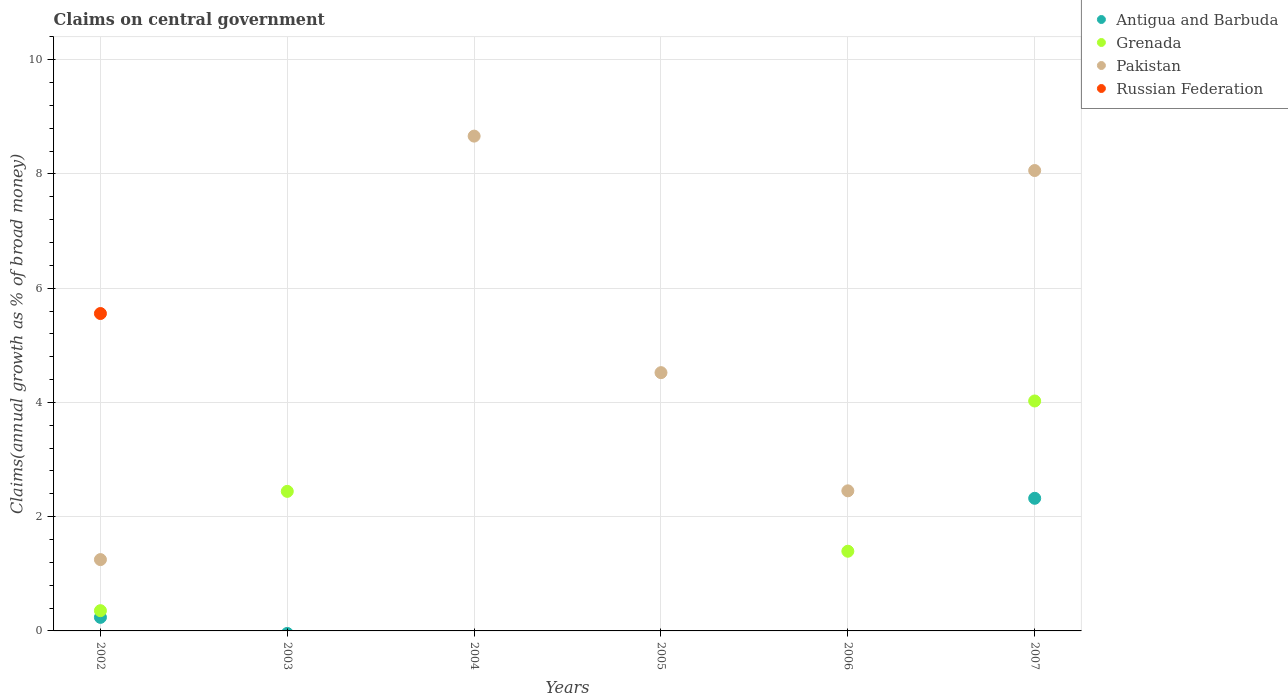Is the number of dotlines equal to the number of legend labels?
Your answer should be compact. No. Across all years, what is the maximum percentage of broad money claimed on centeral government in Russian Federation?
Offer a terse response. 5.56. Across all years, what is the minimum percentage of broad money claimed on centeral government in Pakistan?
Keep it short and to the point. 0. In which year was the percentage of broad money claimed on centeral government in Grenada maximum?
Provide a short and direct response. 2007. What is the total percentage of broad money claimed on centeral government in Russian Federation in the graph?
Provide a short and direct response. 5.56. What is the difference between the percentage of broad money claimed on centeral government in Grenada in 2003 and that in 2007?
Offer a terse response. -1.58. What is the difference between the percentage of broad money claimed on centeral government in Grenada in 2004 and the percentage of broad money claimed on centeral government in Pakistan in 2005?
Your answer should be compact. -4.52. What is the average percentage of broad money claimed on centeral government in Antigua and Barbuda per year?
Make the answer very short. 0.43. In the year 2007, what is the difference between the percentage of broad money claimed on centeral government in Antigua and Barbuda and percentage of broad money claimed on centeral government in Pakistan?
Offer a very short reply. -5.74. In how many years, is the percentage of broad money claimed on centeral government in Antigua and Barbuda greater than 0.8 %?
Ensure brevity in your answer.  1. Is the difference between the percentage of broad money claimed on centeral government in Antigua and Barbuda in 2002 and 2007 greater than the difference between the percentage of broad money claimed on centeral government in Pakistan in 2002 and 2007?
Give a very brief answer. Yes. What is the difference between the highest and the second highest percentage of broad money claimed on centeral government in Grenada?
Your answer should be compact. 1.58. What is the difference between the highest and the lowest percentage of broad money claimed on centeral government in Russian Federation?
Your answer should be compact. 5.56. Is it the case that in every year, the sum of the percentage of broad money claimed on centeral government in Grenada and percentage of broad money claimed on centeral government in Russian Federation  is greater than the sum of percentage of broad money claimed on centeral government in Pakistan and percentage of broad money claimed on centeral government in Antigua and Barbuda?
Provide a short and direct response. No. Is it the case that in every year, the sum of the percentage of broad money claimed on centeral government in Russian Federation and percentage of broad money claimed on centeral government in Grenada  is greater than the percentage of broad money claimed on centeral government in Antigua and Barbuda?
Keep it short and to the point. No. Does the percentage of broad money claimed on centeral government in Antigua and Barbuda monotonically increase over the years?
Ensure brevity in your answer.  No. Is the percentage of broad money claimed on centeral government in Grenada strictly less than the percentage of broad money claimed on centeral government in Russian Federation over the years?
Your answer should be very brief. No. What is the difference between two consecutive major ticks on the Y-axis?
Make the answer very short. 2. Are the values on the major ticks of Y-axis written in scientific E-notation?
Make the answer very short. No. Does the graph contain any zero values?
Your answer should be compact. Yes. Where does the legend appear in the graph?
Keep it short and to the point. Top right. How many legend labels are there?
Offer a very short reply. 4. How are the legend labels stacked?
Provide a short and direct response. Vertical. What is the title of the graph?
Provide a succinct answer. Claims on central government. What is the label or title of the Y-axis?
Your answer should be very brief. Claims(annual growth as % of broad money). What is the Claims(annual growth as % of broad money) in Antigua and Barbuda in 2002?
Provide a short and direct response. 0.24. What is the Claims(annual growth as % of broad money) of Grenada in 2002?
Offer a very short reply. 0.35. What is the Claims(annual growth as % of broad money) of Pakistan in 2002?
Your answer should be compact. 1.25. What is the Claims(annual growth as % of broad money) of Russian Federation in 2002?
Your answer should be very brief. 5.56. What is the Claims(annual growth as % of broad money) of Grenada in 2003?
Give a very brief answer. 2.44. What is the Claims(annual growth as % of broad money) of Antigua and Barbuda in 2004?
Make the answer very short. 0. What is the Claims(annual growth as % of broad money) of Pakistan in 2004?
Offer a very short reply. 8.66. What is the Claims(annual growth as % of broad money) in Antigua and Barbuda in 2005?
Your response must be concise. 0. What is the Claims(annual growth as % of broad money) in Grenada in 2005?
Make the answer very short. 0. What is the Claims(annual growth as % of broad money) of Pakistan in 2005?
Provide a succinct answer. 4.52. What is the Claims(annual growth as % of broad money) in Antigua and Barbuda in 2006?
Your answer should be very brief. 0. What is the Claims(annual growth as % of broad money) of Grenada in 2006?
Your response must be concise. 1.4. What is the Claims(annual growth as % of broad money) of Pakistan in 2006?
Your response must be concise. 2.45. What is the Claims(annual growth as % of broad money) of Antigua and Barbuda in 2007?
Your answer should be compact. 2.32. What is the Claims(annual growth as % of broad money) in Grenada in 2007?
Your response must be concise. 4.03. What is the Claims(annual growth as % of broad money) in Pakistan in 2007?
Provide a short and direct response. 8.06. What is the Claims(annual growth as % of broad money) in Russian Federation in 2007?
Keep it short and to the point. 0. Across all years, what is the maximum Claims(annual growth as % of broad money) of Antigua and Barbuda?
Offer a very short reply. 2.32. Across all years, what is the maximum Claims(annual growth as % of broad money) in Grenada?
Make the answer very short. 4.03. Across all years, what is the maximum Claims(annual growth as % of broad money) of Pakistan?
Offer a very short reply. 8.66. Across all years, what is the maximum Claims(annual growth as % of broad money) of Russian Federation?
Your response must be concise. 5.56. Across all years, what is the minimum Claims(annual growth as % of broad money) of Antigua and Barbuda?
Your answer should be very brief. 0. Across all years, what is the minimum Claims(annual growth as % of broad money) in Russian Federation?
Offer a very short reply. 0. What is the total Claims(annual growth as % of broad money) in Antigua and Barbuda in the graph?
Keep it short and to the point. 2.56. What is the total Claims(annual growth as % of broad money) in Grenada in the graph?
Ensure brevity in your answer.  8.22. What is the total Claims(annual growth as % of broad money) of Pakistan in the graph?
Keep it short and to the point. 24.95. What is the total Claims(annual growth as % of broad money) in Russian Federation in the graph?
Make the answer very short. 5.56. What is the difference between the Claims(annual growth as % of broad money) in Grenada in 2002 and that in 2003?
Your answer should be compact. -2.09. What is the difference between the Claims(annual growth as % of broad money) in Pakistan in 2002 and that in 2004?
Give a very brief answer. -7.41. What is the difference between the Claims(annual growth as % of broad money) in Pakistan in 2002 and that in 2005?
Your response must be concise. -3.27. What is the difference between the Claims(annual growth as % of broad money) in Grenada in 2002 and that in 2006?
Offer a very short reply. -1.04. What is the difference between the Claims(annual growth as % of broad money) of Pakistan in 2002 and that in 2006?
Your response must be concise. -1.2. What is the difference between the Claims(annual growth as % of broad money) in Antigua and Barbuda in 2002 and that in 2007?
Make the answer very short. -2.08. What is the difference between the Claims(annual growth as % of broad money) of Grenada in 2002 and that in 2007?
Make the answer very short. -3.67. What is the difference between the Claims(annual growth as % of broad money) in Pakistan in 2002 and that in 2007?
Offer a terse response. -6.81. What is the difference between the Claims(annual growth as % of broad money) of Grenada in 2003 and that in 2006?
Offer a terse response. 1.05. What is the difference between the Claims(annual growth as % of broad money) of Grenada in 2003 and that in 2007?
Provide a short and direct response. -1.58. What is the difference between the Claims(annual growth as % of broad money) of Pakistan in 2004 and that in 2005?
Give a very brief answer. 4.14. What is the difference between the Claims(annual growth as % of broad money) of Pakistan in 2004 and that in 2006?
Give a very brief answer. 6.21. What is the difference between the Claims(annual growth as % of broad money) of Pakistan in 2004 and that in 2007?
Provide a succinct answer. 0.6. What is the difference between the Claims(annual growth as % of broad money) in Pakistan in 2005 and that in 2006?
Your answer should be very brief. 2.07. What is the difference between the Claims(annual growth as % of broad money) of Pakistan in 2005 and that in 2007?
Your answer should be compact. -3.54. What is the difference between the Claims(annual growth as % of broad money) in Grenada in 2006 and that in 2007?
Make the answer very short. -2.63. What is the difference between the Claims(annual growth as % of broad money) of Pakistan in 2006 and that in 2007?
Give a very brief answer. -5.61. What is the difference between the Claims(annual growth as % of broad money) of Antigua and Barbuda in 2002 and the Claims(annual growth as % of broad money) of Grenada in 2003?
Offer a very short reply. -2.21. What is the difference between the Claims(annual growth as % of broad money) in Antigua and Barbuda in 2002 and the Claims(annual growth as % of broad money) in Pakistan in 2004?
Your answer should be very brief. -8.43. What is the difference between the Claims(annual growth as % of broad money) in Grenada in 2002 and the Claims(annual growth as % of broad money) in Pakistan in 2004?
Your response must be concise. -8.31. What is the difference between the Claims(annual growth as % of broad money) in Antigua and Barbuda in 2002 and the Claims(annual growth as % of broad money) in Pakistan in 2005?
Make the answer very short. -4.28. What is the difference between the Claims(annual growth as % of broad money) in Grenada in 2002 and the Claims(annual growth as % of broad money) in Pakistan in 2005?
Offer a very short reply. -4.17. What is the difference between the Claims(annual growth as % of broad money) in Antigua and Barbuda in 2002 and the Claims(annual growth as % of broad money) in Grenada in 2006?
Offer a terse response. -1.16. What is the difference between the Claims(annual growth as % of broad money) in Antigua and Barbuda in 2002 and the Claims(annual growth as % of broad money) in Pakistan in 2006?
Your answer should be very brief. -2.22. What is the difference between the Claims(annual growth as % of broad money) of Grenada in 2002 and the Claims(annual growth as % of broad money) of Pakistan in 2006?
Offer a terse response. -2.1. What is the difference between the Claims(annual growth as % of broad money) in Antigua and Barbuda in 2002 and the Claims(annual growth as % of broad money) in Grenada in 2007?
Give a very brief answer. -3.79. What is the difference between the Claims(annual growth as % of broad money) of Antigua and Barbuda in 2002 and the Claims(annual growth as % of broad money) of Pakistan in 2007?
Offer a very short reply. -7.82. What is the difference between the Claims(annual growth as % of broad money) of Grenada in 2002 and the Claims(annual growth as % of broad money) of Pakistan in 2007?
Your response must be concise. -7.71. What is the difference between the Claims(annual growth as % of broad money) of Grenada in 2003 and the Claims(annual growth as % of broad money) of Pakistan in 2004?
Offer a terse response. -6.22. What is the difference between the Claims(annual growth as % of broad money) in Grenada in 2003 and the Claims(annual growth as % of broad money) in Pakistan in 2005?
Provide a short and direct response. -2.08. What is the difference between the Claims(annual growth as % of broad money) of Grenada in 2003 and the Claims(annual growth as % of broad money) of Pakistan in 2006?
Offer a terse response. -0.01. What is the difference between the Claims(annual growth as % of broad money) in Grenada in 2003 and the Claims(annual growth as % of broad money) in Pakistan in 2007?
Provide a short and direct response. -5.62. What is the difference between the Claims(annual growth as % of broad money) in Grenada in 2006 and the Claims(annual growth as % of broad money) in Pakistan in 2007?
Ensure brevity in your answer.  -6.67. What is the average Claims(annual growth as % of broad money) of Antigua and Barbuda per year?
Offer a terse response. 0.43. What is the average Claims(annual growth as % of broad money) of Grenada per year?
Ensure brevity in your answer.  1.37. What is the average Claims(annual growth as % of broad money) in Pakistan per year?
Provide a short and direct response. 4.16. What is the average Claims(annual growth as % of broad money) in Russian Federation per year?
Keep it short and to the point. 0.93. In the year 2002, what is the difference between the Claims(annual growth as % of broad money) of Antigua and Barbuda and Claims(annual growth as % of broad money) of Grenada?
Offer a terse response. -0.12. In the year 2002, what is the difference between the Claims(annual growth as % of broad money) of Antigua and Barbuda and Claims(annual growth as % of broad money) of Pakistan?
Provide a short and direct response. -1.01. In the year 2002, what is the difference between the Claims(annual growth as % of broad money) in Antigua and Barbuda and Claims(annual growth as % of broad money) in Russian Federation?
Provide a succinct answer. -5.32. In the year 2002, what is the difference between the Claims(annual growth as % of broad money) of Grenada and Claims(annual growth as % of broad money) of Pakistan?
Provide a short and direct response. -0.89. In the year 2002, what is the difference between the Claims(annual growth as % of broad money) of Grenada and Claims(annual growth as % of broad money) of Russian Federation?
Your response must be concise. -5.2. In the year 2002, what is the difference between the Claims(annual growth as % of broad money) in Pakistan and Claims(annual growth as % of broad money) in Russian Federation?
Your answer should be compact. -4.31. In the year 2006, what is the difference between the Claims(annual growth as % of broad money) in Grenada and Claims(annual growth as % of broad money) in Pakistan?
Your answer should be compact. -1.06. In the year 2007, what is the difference between the Claims(annual growth as % of broad money) of Antigua and Barbuda and Claims(annual growth as % of broad money) of Grenada?
Your answer should be compact. -1.7. In the year 2007, what is the difference between the Claims(annual growth as % of broad money) of Antigua and Barbuda and Claims(annual growth as % of broad money) of Pakistan?
Keep it short and to the point. -5.74. In the year 2007, what is the difference between the Claims(annual growth as % of broad money) of Grenada and Claims(annual growth as % of broad money) of Pakistan?
Keep it short and to the point. -4.03. What is the ratio of the Claims(annual growth as % of broad money) in Grenada in 2002 to that in 2003?
Your response must be concise. 0.15. What is the ratio of the Claims(annual growth as % of broad money) of Pakistan in 2002 to that in 2004?
Keep it short and to the point. 0.14. What is the ratio of the Claims(annual growth as % of broad money) in Pakistan in 2002 to that in 2005?
Keep it short and to the point. 0.28. What is the ratio of the Claims(annual growth as % of broad money) of Grenada in 2002 to that in 2006?
Provide a short and direct response. 0.25. What is the ratio of the Claims(annual growth as % of broad money) of Pakistan in 2002 to that in 2006?
Ensure brevity in your answer.  0.51. What is the ratio of the Claims(annual growth as % of broad money) of Antigua and Barbuda in 2002 to that in 2007?
Keep it short and to the point. 0.1. What is the ratio of the Claims(annual growth as % of broad money) of Grenada in 2002 to that in 2007?
Offer a terse response. 0.09. What is the ratio of the Claims(annual growth as % of broad money) of Pakistan in 2002 to that in 2007?
Offer a very short reply. 0.15. What is the ratio of the Claims(annual growth as % of broad money) of Grenada in 2003 to that in 2006?
Offer a terse response. 1.75. What is the ratio of the Claims(annual growth as % of broad money) of Grenada in 2003 to that in 2007?
Offer a terse response. 0.61. What is the ratio of the Claims(annual growth as % of broad money) of Pakistan in 2004 to that in 2005?
Ensure brevity in your answer.  1.92. What is the ratio of the Claims(annual growth as % of broad money) in Pakistan in 2004 to that in 2006?
Your answer should be compact. 3.53. What is the ratio of the Claims(annual growth as % of broad money) in Pakistan in 2004 to that in 2007?
Your answer should be compact. 1.07. What is the ratio of the Claims(annual growth as % of broad money) in Pakistan in 2005 to that in 2006?
Your answer should be compact. 1.84. What is the ratio of the Claims(annual growth as % of broad money) of Pakistan in 2005 to that in 2007?
Offer a terse response. 0.56. What is the ratio of the Claims(annual growth as % of broad money) in Grenada in 2006 to that in 2007?
Ensure brevity in your answer.  0.35. What is the ratio of the Claims(annual growth as % of broad money) of Pakistan in 2006 to that in 2007?
Ensure brevity in your answer.  0.3. What is the difference between the highest and the second highest Claims(annual growth as % of broad money) in Grenada?
Ensure brevity in your answer.  1.58. What is the difference between the highest and the second highest Claims(annual growth as % of broad money) in Pakistan?
Give a very brief answer. 0.6. What is the difference between the highest and the lowest Claims(annual growth as % of broad money) in Antigua and Barbuda?
Your answer should be very brief. 2.32. What is the difference between the highest and the lowest Claims(annual growth as % of broad money) in Grenada?
Your response must be concise. 4.03. What is the difference between the highest and the lowest Claims(annual growth as % of broad money) in Pakistan?
Your answer should be compact. 8.66. What is the difference between the highest and the lowest Claims(annual growth as % of broad money) of Russian Federation?
Ensure brevity in your answer.  5.56. 